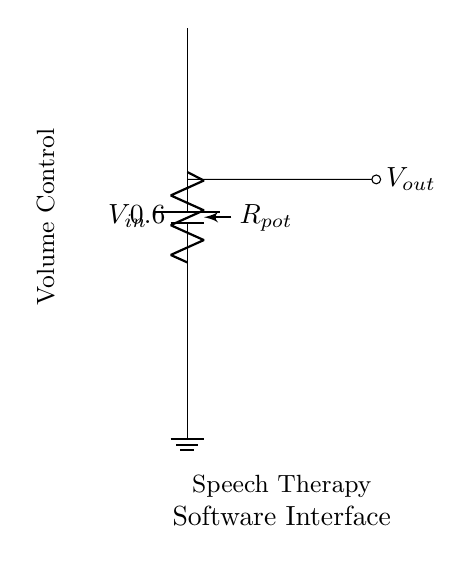What is the function of the potentiometer in this circuit? The potentiometer functions as a variable resistor, allowing for adjustable resistance which controls the output voltage.
Answer: Variable resistor What component determines the output voltage in this circuit? The output voltage is determined by the position of the potentiometer, which changes the voltage division ratio based on its resistance setting.
Answer: Potentiometer What type of circuit is represented in this diagram? This circuit is a voltage divider, specifically using a potentiometer to adjust the output voltage for volume control.
Answer: Voltage divider What does the label next to the battery indicate? The label next to the battery indicates the input voltage supply of the circuit, which is the voltage provided to the potentiometer.
Answer: V in If the potentiometer is turned to maximum resistance, what happens to the output voltage? If the potentiometer is turned to maximum resistance, the output voltage approaches the input voltage, as little to no voltage is dropped across the potentiometer.
Answer: Approaches V in What is the purpose of the circuit in terms of its application? The circuit is designed for controlling the volume in speech therapy software interfaces, allowing therapists to adjust audio output easily.
Answer: Volume control 